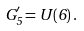<formula> <loc_0><loc_0><loc_500><loc_500>G ^ { \prime } _ { 5 } = U ( 6 ) \, .</formula> 